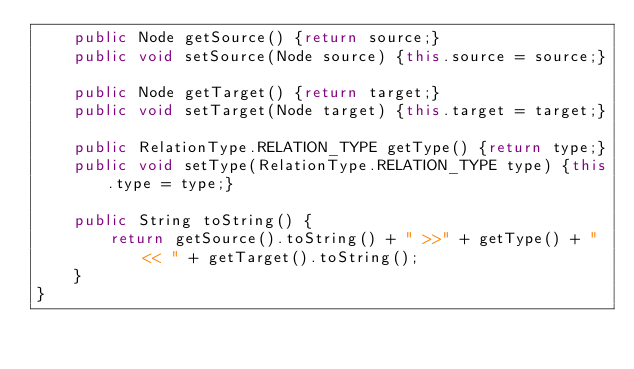<code> <loc_0><loc_0><loc_500><loc_500><_Java_>    public Node getSource() {return source;}
    public void setSource(Node source) {this.source = source;}

    public Node getTarget() {return target;}
    public void setTarget(Node target) {this.target = target;}

    public RelationType.RELATION_TYPE getType() {return type;}
    public void setType(RelationType.RELATION_TYPE type) {this.type = type;}

    public String toString() {
        return getSource().toString() + " >>" + getType() + "<< " + getTarget().toString();
    }
}
</code> 